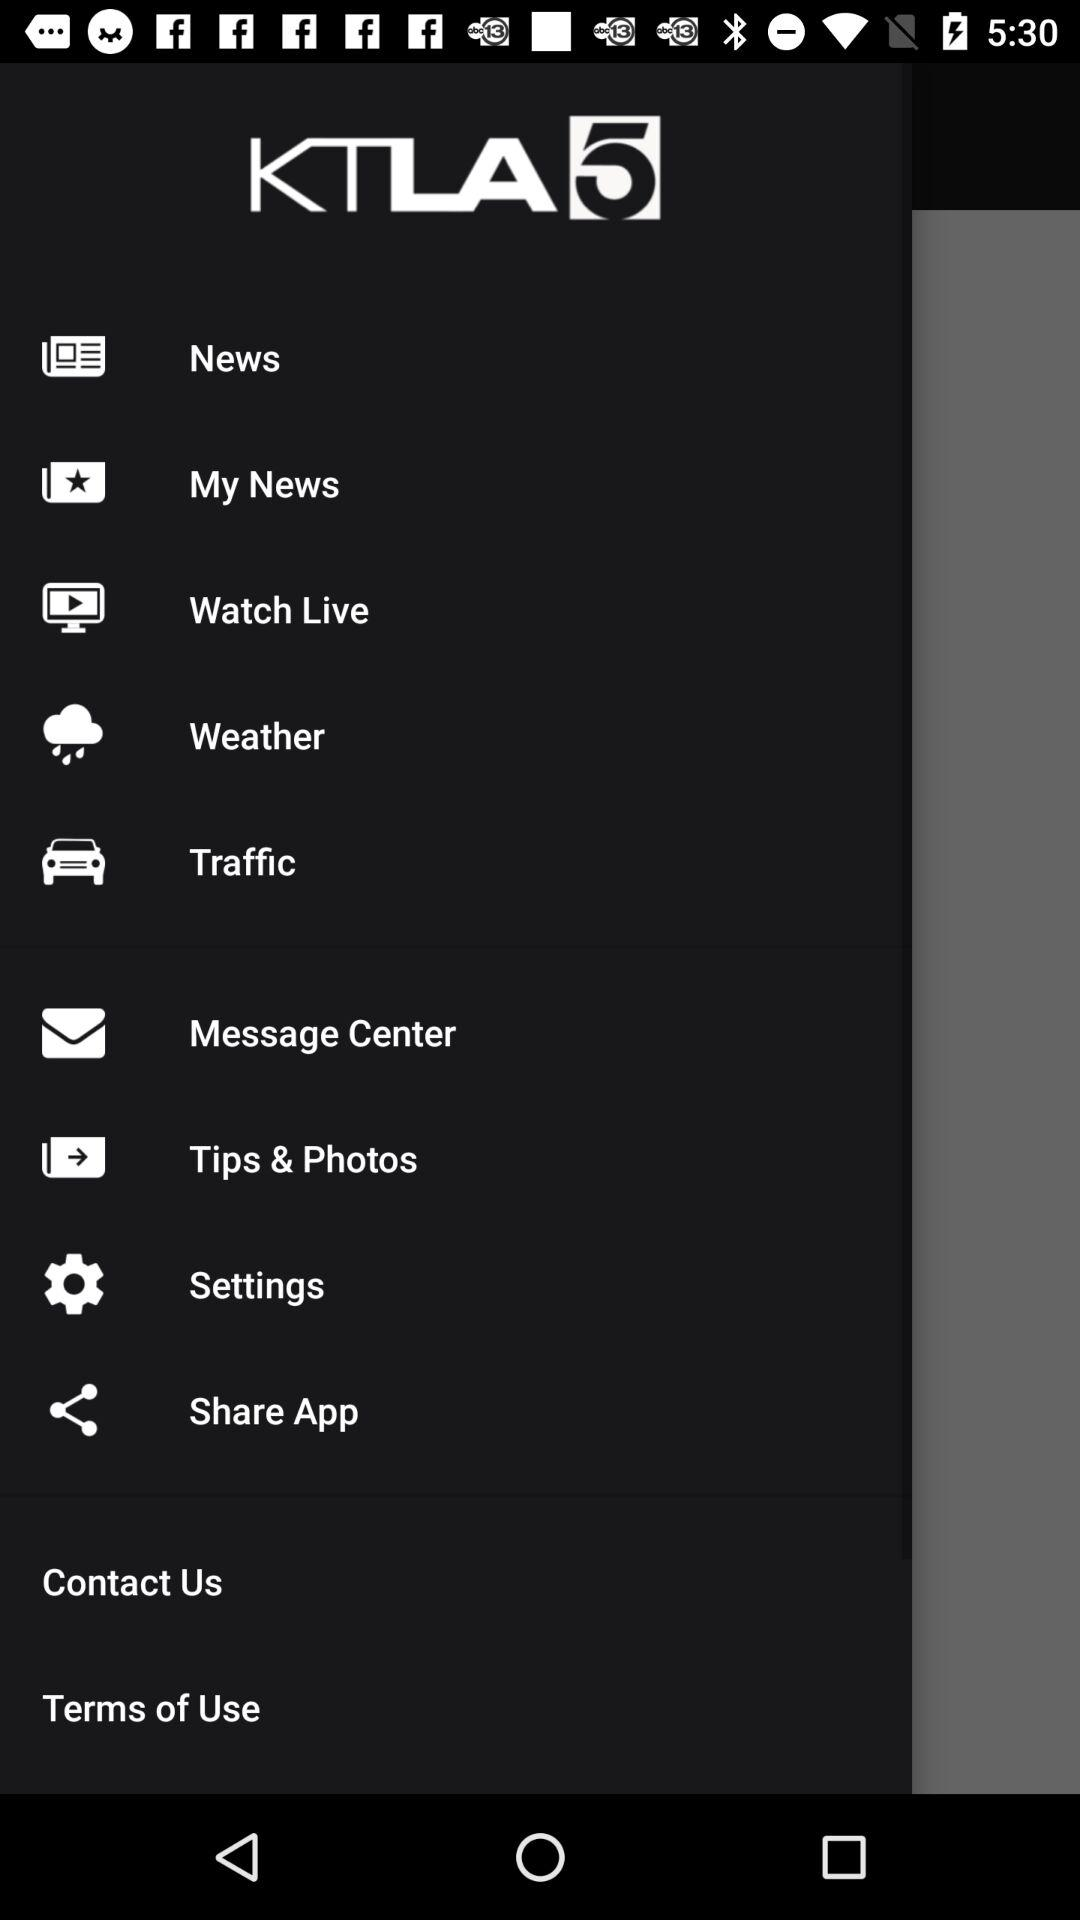How many notifications are there in "Message Center"?
When the provided information is insufficient, respond with <no answer>. <no answer> 